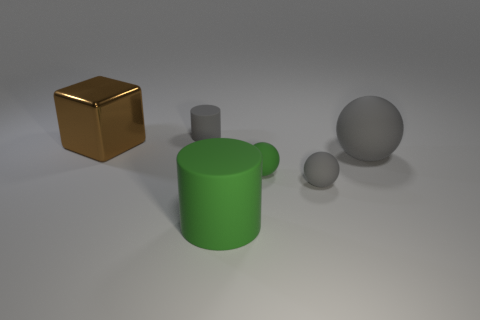How many tiny matte cylinders are in front of the brown shiny block? 0 